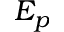Convert formula to latex. <formula><loc_0><loc_0><loc_500><loc_500>E _ { p }</formula> 